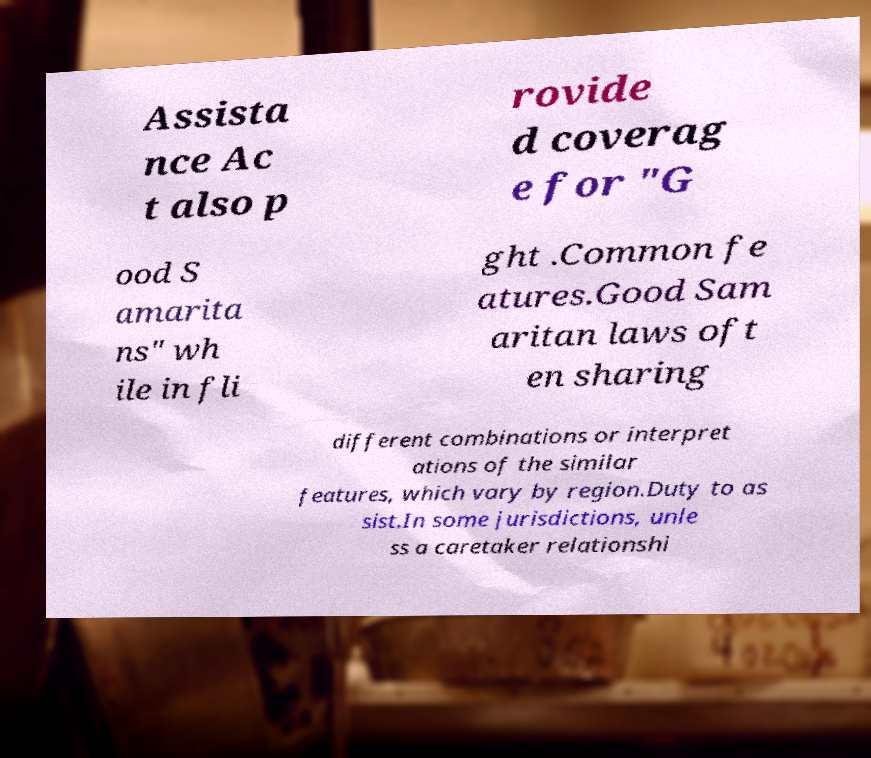There's text embedded in this image that I need extracted. Can you transcribe it verbatim? Assista nce Ac t also p rovide d coverag e for "G ood S amarita ns" wh ile in fli ght .Common fe atures.Good Sam aritan laws oft en sharing different combinations or interpret ations of the similar features, which vary by region.Duty to as sist.In some jurisdictions, unle ss a caretaker relationshi 